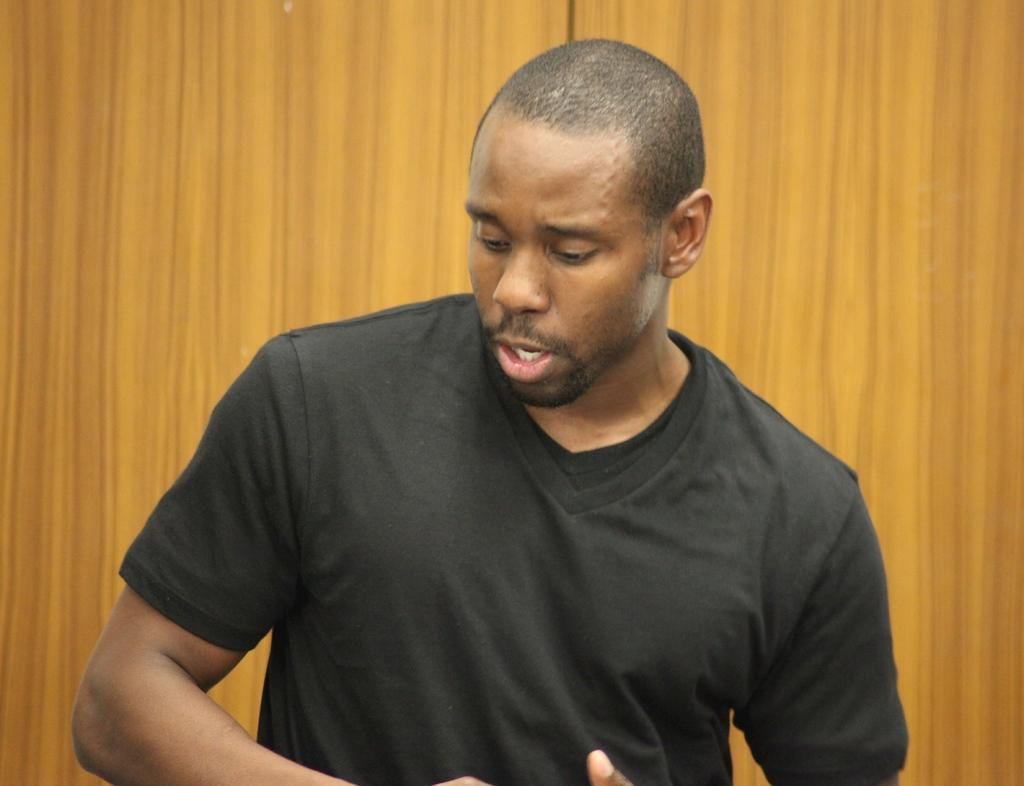Where was the image taken? The image was taken indoors. What is the main subject in the foreground of the image? There is a man in the foreground of the image. What is the man wearing? The man is wearing a black t-shirt. What is the man doing in the image? The man is standing and appears to be talking. What can be seen in the background of the image? There is a wooden object in the background of the image. What type of pancake is being served on the wooden object in the background? There is no pancake present in the image, and the wooden object in the background does not appear to be serving any food. 